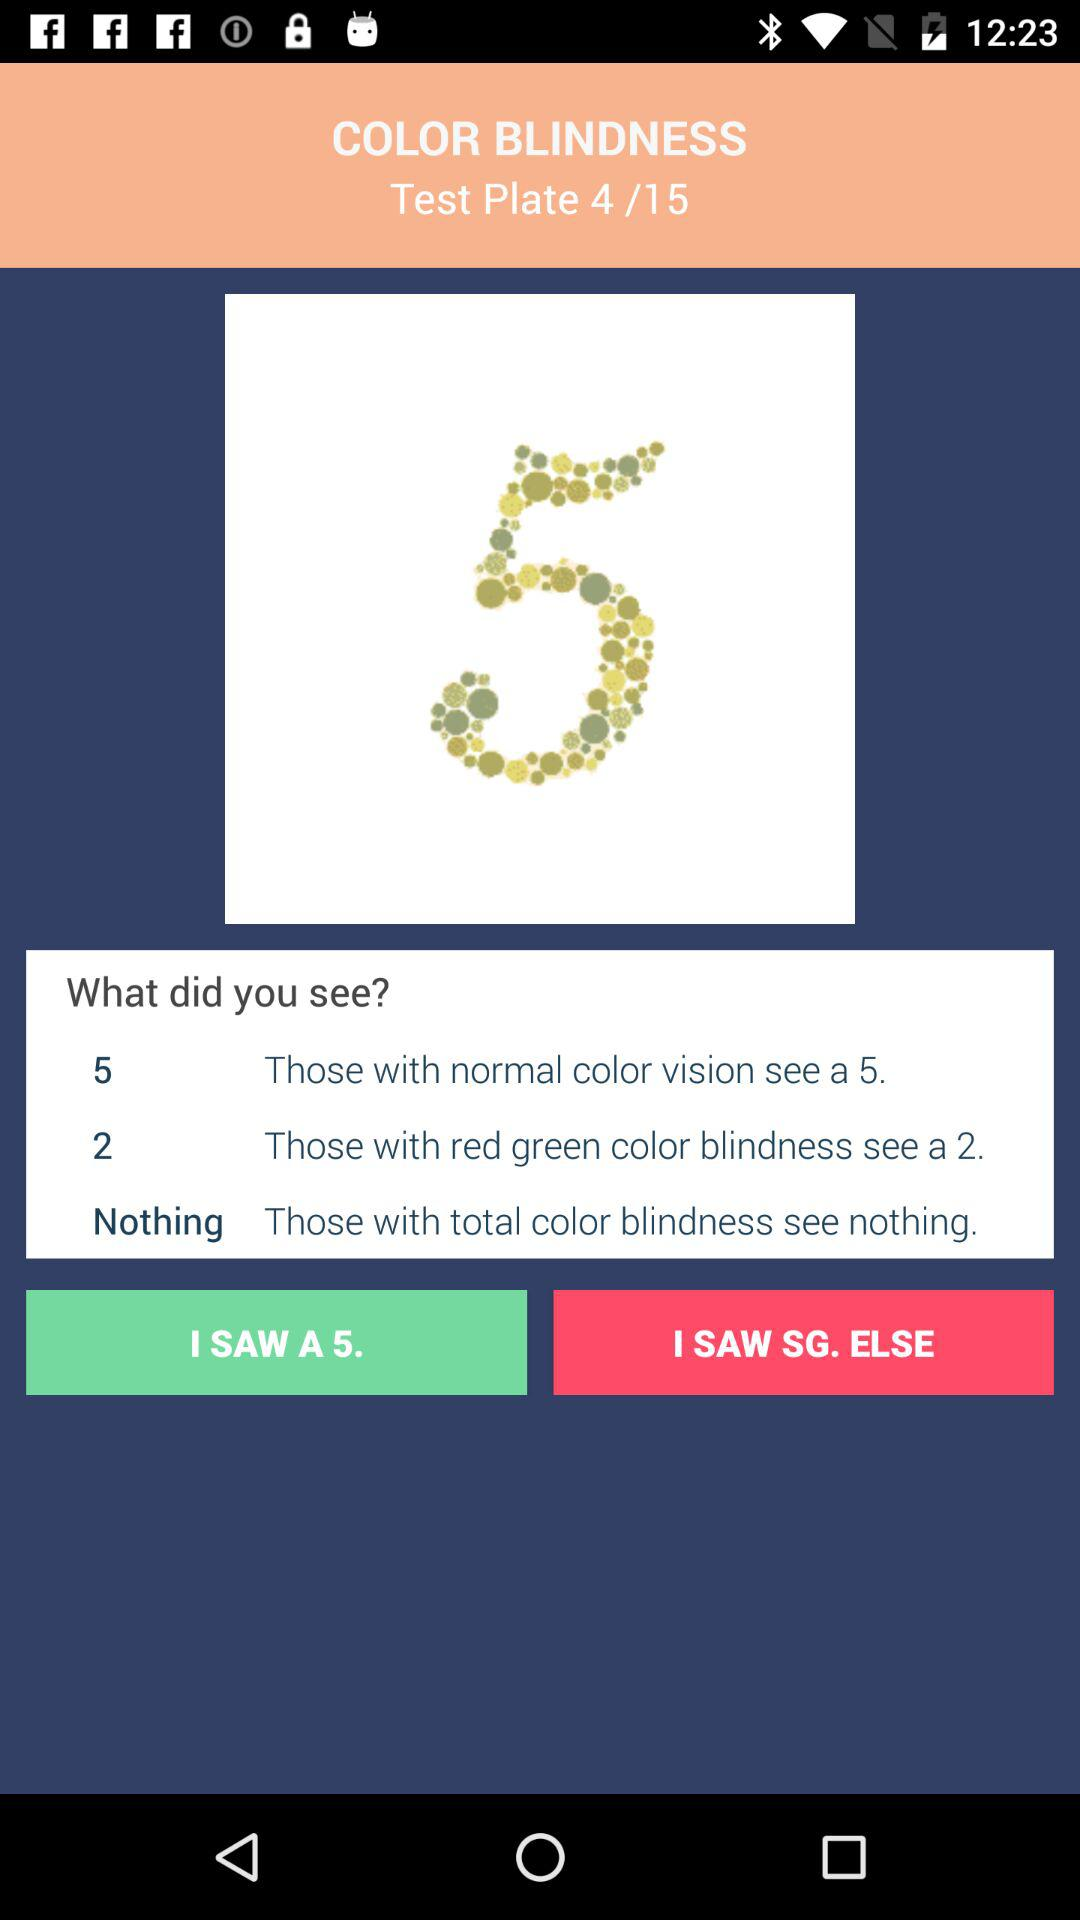How many options are there for people with total color blindness?
Answer the question using a single word or phrase. 1 